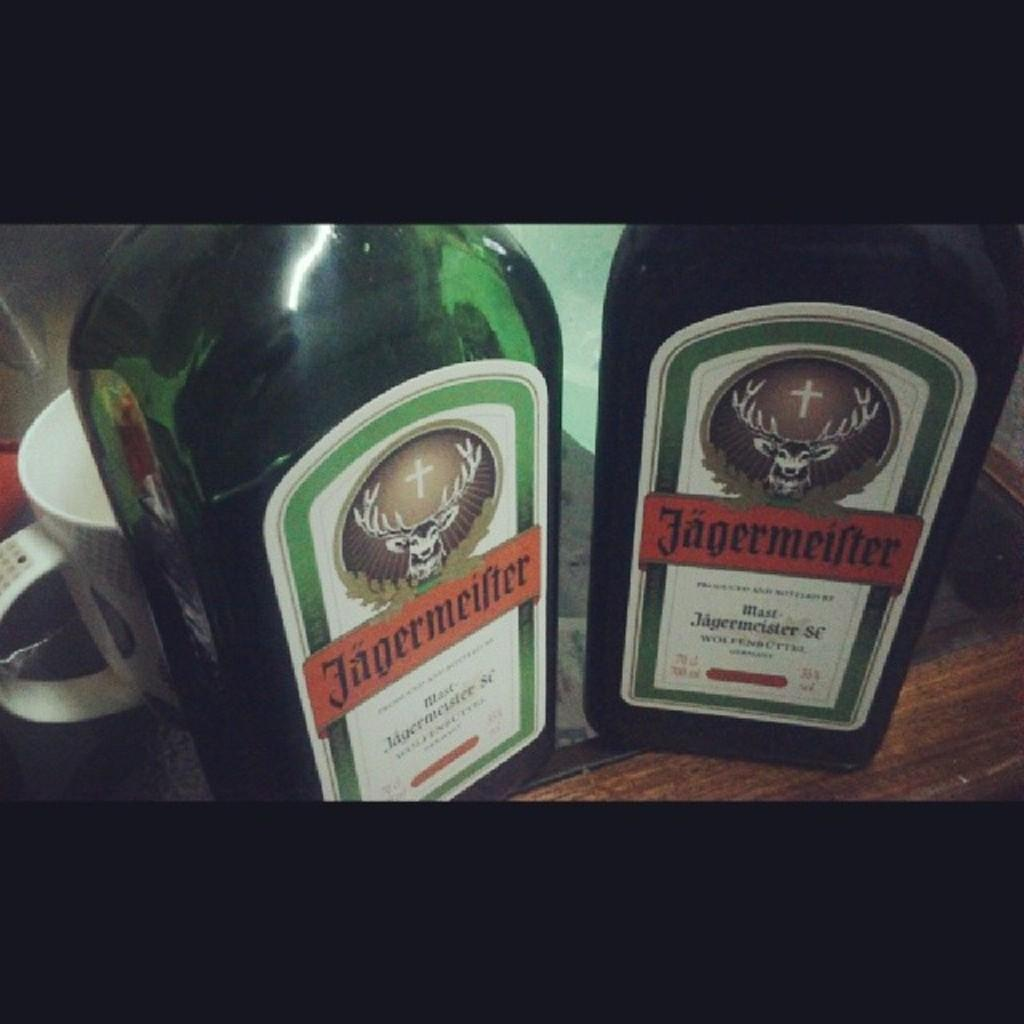How many bottles are on the table in the image? There are two bottles on the table in the image. What other type of container is on the table? There is a cup on the table. What type of doctor is attending to the wax in the image? There is no doctor or wax present in the image. How does the pain affect the objects in the image? There is no pain present in the image, as it only features two bottles and a cup on a table. 